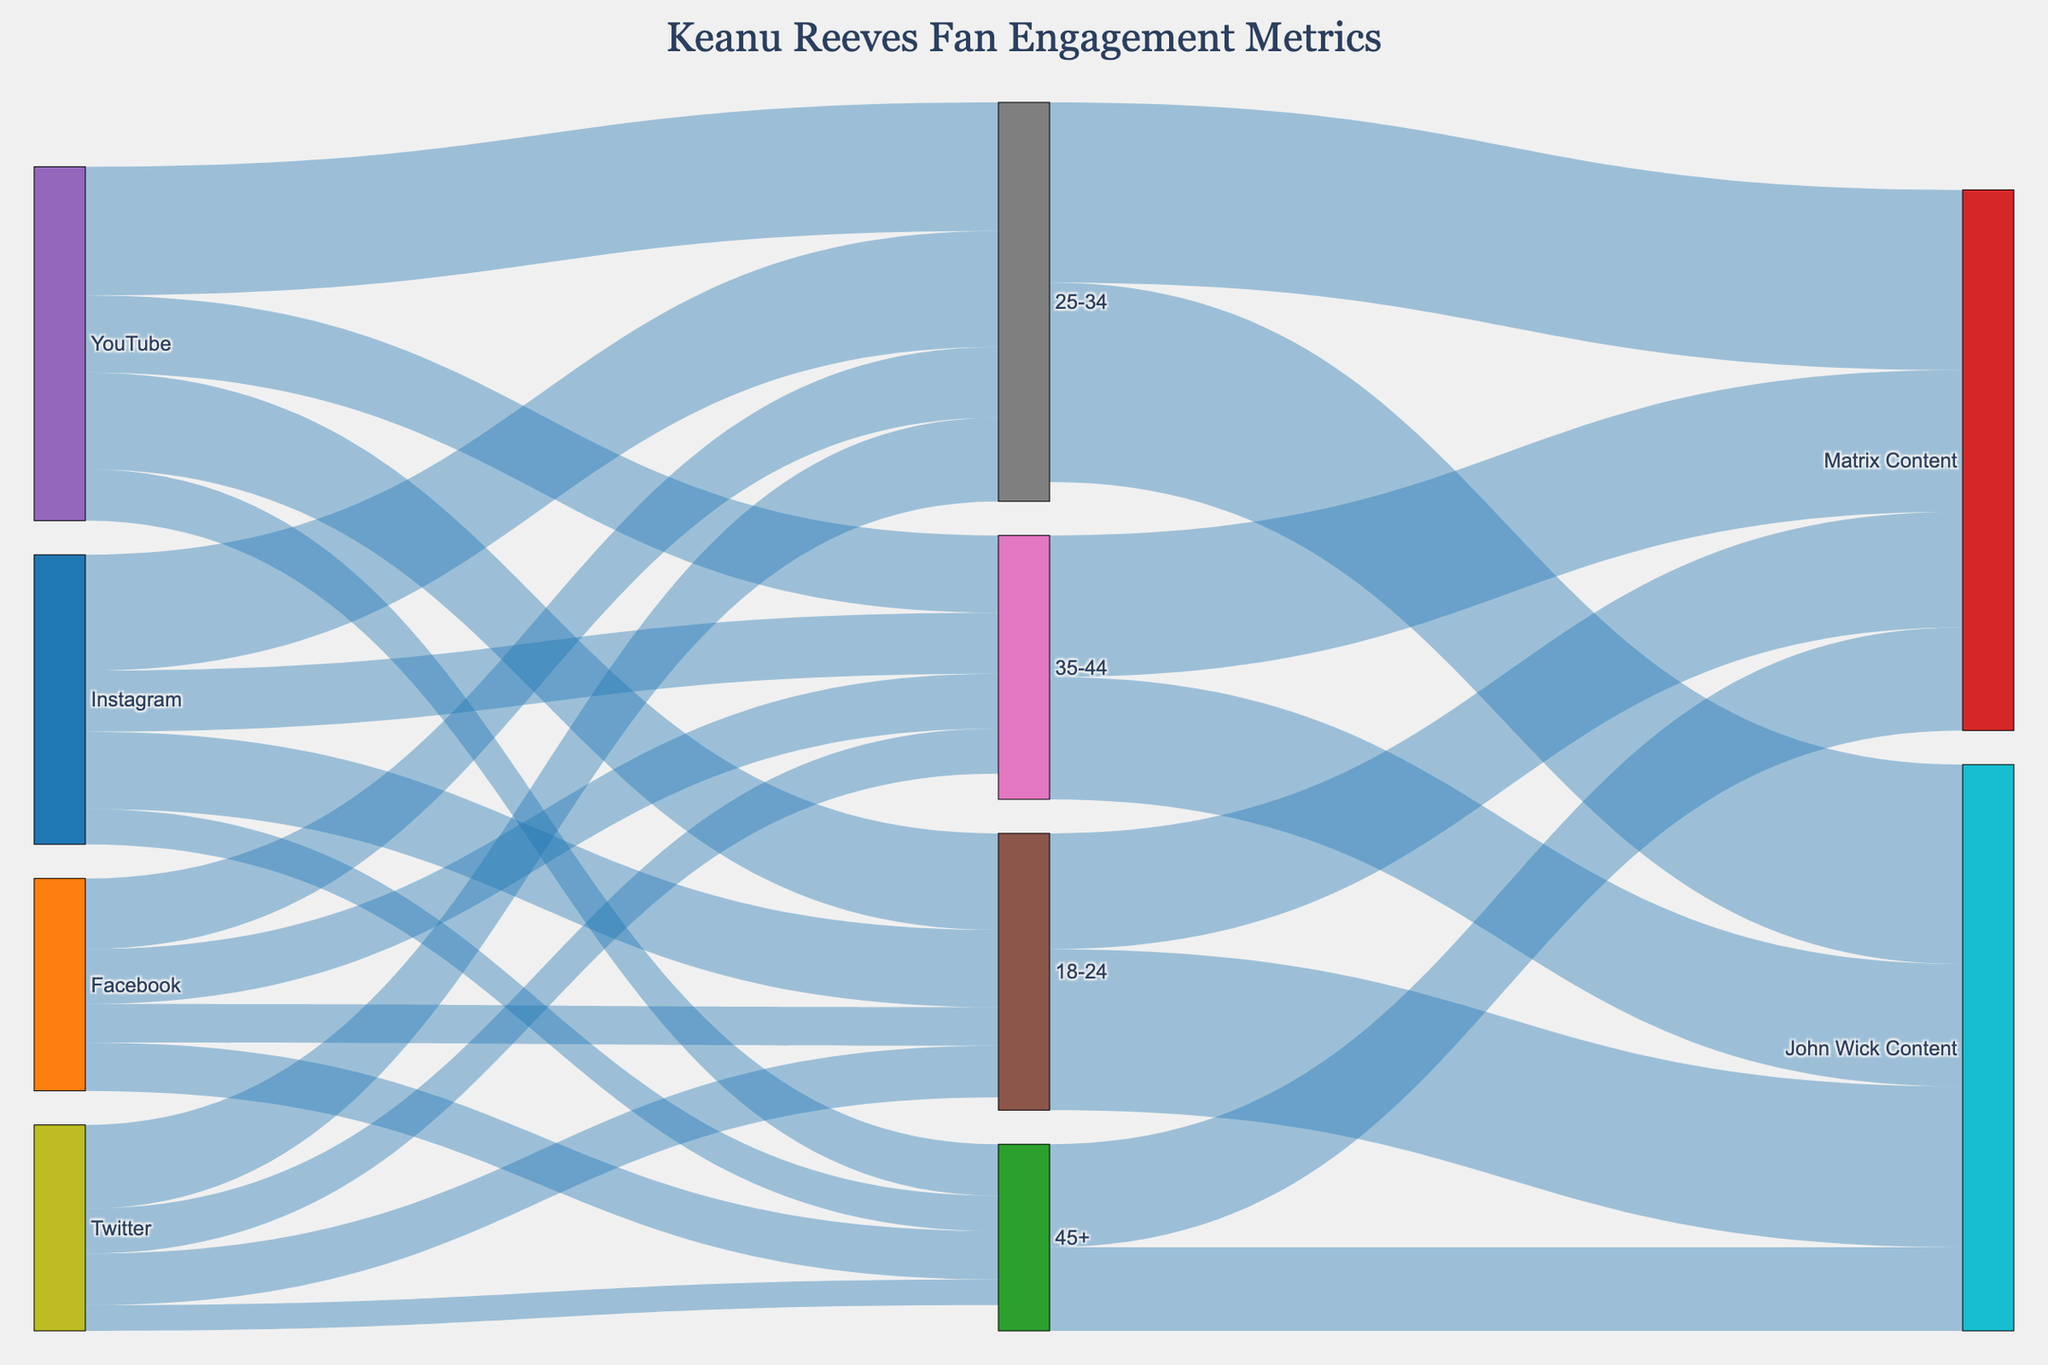What is the title of the Sankey Diagram? The title of the diagram is typically displayed at the top center of the figure.
Answer: Keanu Reeves Fan Engagement Metrics Which social media platform has the highest fan engagement for the 25-34 age group? The Sankey Diagram shows flows from each social media platform to the 25-34 age group. By comparing the values of these flows, YouTube has the highest fan engagement for the 25-34 age group.
Answer: YouTube How many fans aged 35-44 engage with Facebook? The Sankey Diagram displays flows from Facebook to various age groups. By examining the flow from Facebook to the 35-44 age group, it shows the engagement value.
Answer: 850,000 Which content is more popular among fans aged 18-24: John Wick or Matrix content? The Sankey Diagram includes flows from the 18-24 age group to different content types. By comparing the values of these flows, John Wick content has more engagement from the 18-24 age group than Matrix content.
Answer: John Wick What is the total fan engagement on Instagram across all age groups? To find the total fan engagement on Instagram, sum the engagement values for all age groups connected to Instagram.
1,200,000 (18-24) + 1,800,000 (25-34) + 950,000 (35-44) + 550,000 (45+) = 4,500,000
Answer: 4,500,000 Across all age groups, how does Twitter's fan engagement compare to Facebook's fan engagement? By summing the engagement values for all age groups connected to Twitter and comparing it to the sum for Facebook:
Twitter: 800,000 (18-24) + 1,300,000 (25-34) + 700,000 (35-44) + 400,000 (45+) = 3,200,000
Facebook: 600,000 (18-24) + 1,100,000 (25-34) + 850,000 (35-44) + 750,000 (45+) = 3,300,000
Facebook has a slightly higher engagement than Twitter.
Answer: Facebook Which age group has the lowest engagement with YouTube? By comparing the values for each age group connected to YouTube, the age group 45+ has the lowest engagement.
Answer: 45+ What is the total engagement for John Wick content across all age groups? To find the total engagement for John Wick content, sum the engagement values for all age groups connected to John Wick content.
2,500,000 (18-24) + 3,100,000 (25-34) + 1,900,000 (35-44) + 1,300,000 (45+) = 8,800,000
Answer: 8,800,000 What percentage of total YouTube engagement comes from the 25-34 age group? First, find the total engagement for YouTube by summing the values for all age groups: 
1,500,000 (18-24) + 2,000,000 (25-34) + 1,200,000 (35-44) + 800,000 (45+) = 5,500,000.
Then divide the 25-34 age group's engagement by the total and multiply by 100:
(2,000,000 / 5,500,000) * 100 ≈ 36.36%
Answer: 36.36% 